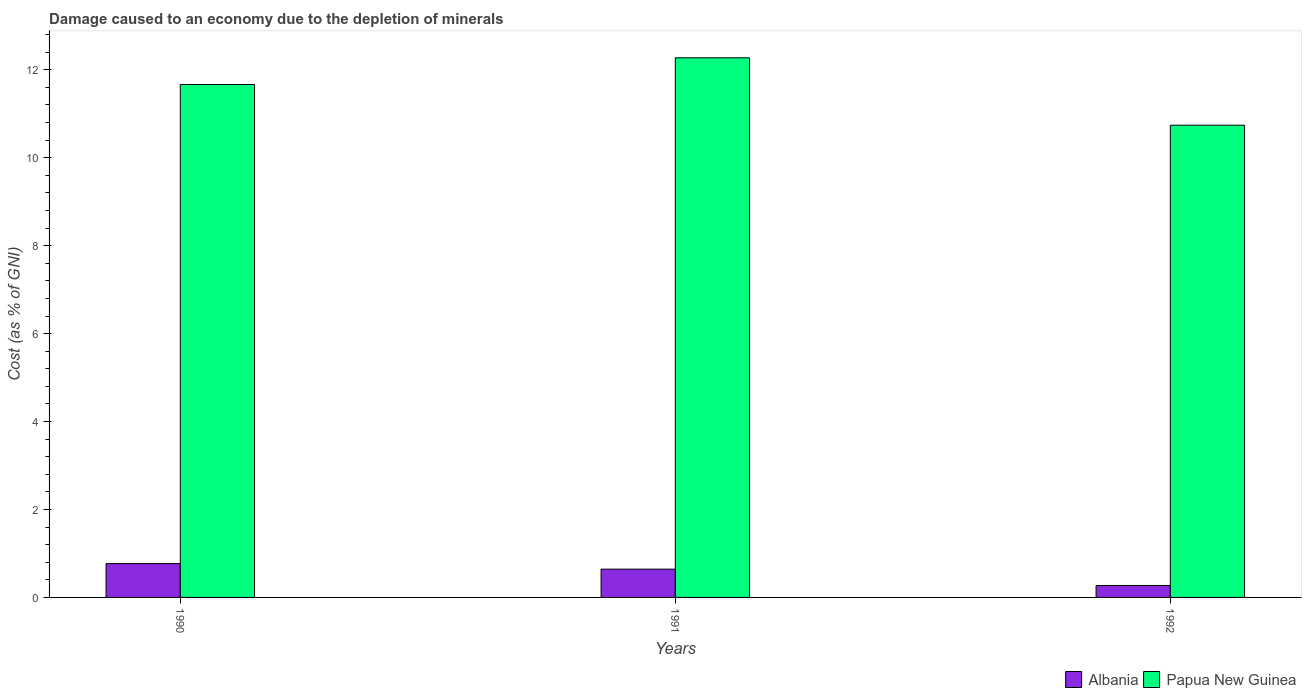Are the number of bars per tick equal to the number of legend labels?
Offer a very short reply. Yes. Are the number of bars on each tick of the X-axis equal?
Your answer should be very brief. Yes. How many bars are there on the 1st tick from the left?
Your response must be concise. 2. How many bars are there on the 3rd tick from the right?
Your response must be concise. 2. What is the label of the 1st group of bars from the left?
Your answer should be very brief. 1990. In how many cases, is the number of bars for a given year not equal to the number of legend labels?
Make the answer very short. 0. What is the cost of damage caused due to the depletion of minerals in Albania in 1991?
Provide a succinct answer. 0.64. Across all years, what is the maximum cost of damage caused due to the depletion of minerals in Albania?
Provide a succinct answer. 0.77. Across all years, what is the minimum cost of damage caused due to the depletion of minerals in Albania?
Your answer should be compact. 0.27. In which year was the cost of damage caused due to the depletion of minerals in Papua New Guinea maximum?
Provide a succinct answer. 1991. In which year was the cost of damage caused due to the depletion of minerals in Papua New Guinea minimum?
Your answer should be very brief. 1992. What is the total cost of damage caused due to the depletion of minerals in Papua New Guinea in the graph?
Provide a short and direct response. 34.68. What is the difference between the cost of damage caused due to the depletion of minerals in Papua New Guinea in 1991 and that in 1992?
Give a very brief answer. 1.53. What is the difference between the cost of damage caused due to the depletion of minerals in Albania in 1992 and the cost of damage caused due to the depletion of minerals in Papua New Guinea in 1990?
Give a very brief answer. -11.4. What is the average cost of damage caused due to the depletion of minerals in Papua New Guinea per year?
Your answer should be compact. 11.56. In the year 1991, what is the difference between the cost of damage caused due to the depletion of minerals in Albania and cost of damage caused due to the depletion of minerals in Papua New Guinea?
Your response must be concise. -11.63. In how many years, is the cost of damage caused due to the depletion of minerals in Albania greater than 8 %?
Your response must be concise. 0. What is the ratio of the cost of damage caused due to the depletion of minerals in Albania in 1990 to that in 1991?
Provide a succinct answer. 1.2. What is the difference between the highest and the second highest cost of damage caused due to the depletion of minerals in Papua New Guinea?
Offer a very short reply. 0.61. What is the difference between the highest and the lowest cost of damage caused due to the depletion of minerals in Albania?
Provide a short and direct response. 0.5. In how many years, is the cost of damage caused due to the depletion of minerals in Papua New Guinea greater than the average cost of damage caused due to the depletion of minerals in Papua New Guinea taken over all years?
Ensure brevity in your answer.  2. What does the 1st bar from the left in 1991 represents?
Your answer should be compact. Albania. What does the 1st bar from the right in 1990 represents?
Keep it short and to the point. Papua New Guinea. How many bars are there?
Offer a terse response. 6. Are all the bars in the graph horizontal?
Ensure brevity in your answer.  No. Are the values on the major ticks of Y-axis written in scientific E-notation?
Offer a terse response. No. Does the graph contain any zero values?
Your response must be concise. No. What is the title of the graph?
Keep it short and to the point. Damage caused to an economy due to the depletion of minerals. Does "Solomon Islands" appear as one of the legend labels in the graph?
Your answer should be compact. No. What is the label or title of the X-axis?
Your answer should be very brief. Years. What is the label or title of the Y-axis?
Provide a short and direct response. Cost (as % of GNI). What is the Cost (as % of GNI) in Albania in 1990?
Offer a very short reply. 0.77. What is the Cost (as % of GNI) of Papua New Guinea in 1990?
Your response must be concise. 11.67. What is the Cost (as % of GNI) of Albania in 1991?
Give a very brief answer. 0.64. What is the Cost (as % of GNI) in Papua New Guinea in 1991?
Offer a very short reply. 12.27. What is the Cost (as % of GNI) of Albania in 1992?
Offer a very short reply. 0.27. What is the Cost (as % of GNI) in Papua New Guinea in 1992?
Keep it short and to the point. 10.74. Across all years, what is the maximum Cost (as % of GNI) in Albania?
Your response must be concise. 0.77. Across all years, what is the maximum Cost (as % of GNI) in Papua New Guinea?
Make the answer very short. 12.27. Across all years, what is the minimum Cost (as % of GNI) of Albania?
Make the answer very short. 0.27. Across all years, what is the minimum Cost (as % of GNI) of Papua New Guinea?
Your answer should be very brief. 10.74. What is the total Cost (as % of GNI) in Albania in the graph?
Your answer should be compact. 1.68. What is the total Cost (as % of GNI) of Papua New Guinea in the graph?
Offer a terse response. 34.68. What is the difference between the Cost (as % of GNI) in Albania in 1990 and that in 1991?
Your response must be concise. 0.13. What is the difference between the Cost (as % of GNI) in Papua New Guinea in 1990 and that in 1991?
Provide a succinct answer. -0.61. What is the difference between the Cost (as % of GNI) in Albania in 1990 and that in 1992?
Give a very brief answer. 0.5. What is the difference between the Cost (as % of GNI) in Papua New Guinea in 1990 and that in 1992?
Your answer should be compact. 0.93. What is the difference between the Cost (as % of GNI) of Albania in 1991 and that in 1992?
Your answer should be compact. 0.37. What is the difference between the Cost (as % of GNI) in Papua New Guinea in 1991 and that in 1992?
Your answer should be compact. 1.53. What is the difference between the Cost (as % of GNI) in Albania in 1990 and the Cost (as % of GNI) in Papua New Guinea in 1991?
Make the answer very short. -11.5. What is the difference between the Cost (as % of GNI) of Albania in 1990 and the Cost (as % of GNI) of Papua New Guinea in 1992?
Provide a succinct answer. -9.97. What is the difference between the Cost (as % of GNI) in Albania in 1991 and the Cost (as % of GNI) in Papua New Guinea in 1992?
Make the answer very short. -10.1. What is the average Cost (as % of GNI) in Albania per year?
Ensure brevity in your answer.  0.56. What is the average Cost (as % of GNI) of Papua New Guinea per year?
Your answer should be compact. 11.56. In the year 1990, what is the difference between the Cost (as % of GNI) of Albania and Cost (as % of GNI) of Papua New Guinea?
Offer a very short reply. -10.9. In the year 1991, what is the difference between the Cost (as % of GNI) of Albania and Cost (as % of GNI) of Papua New Guinea?
Your answer should be compact. -11.63. In the year 1992, what is the difference between the Cost (as % of GNI) in Albania and Cost (as % of GNI) in Papua New Guinea?
Provide a short and direct response. -10.47. What is the ratio of the Cost (as % of GNI) in Albania in 1990 to that in 1991?
Make the answer very short. 1.2. What is the ratio of the Cost (as % of GNI) in Papua New Guinea in 1990 to that in 1991?
Your answer should be compact. 0.95. What is the ratio of the Cost (as % of GNI) in Albania in 1990 to that in 1992?
Make the answer very short. 2.83. What is the ratio of the Cost (as % of GNI) of Papua New Guinea in 1990 to that in 1992?
Offer a very short reply. 1.09. What is the ratio of the Cost (as % of GNI) of Albania in 1991 to that in 1992?
Keep it short and to the point. 2.37. What is the ratio of the Cost (as % of GNI) in Papua New Guinea in 1991 to that in 1992?
Provide a short and direct response. 1.14. What is the difference between the highest and the second highest Cost (as % of GNI) of Albania?
Keep it short and to the point. 0.13. What is the difference between the highest and the second highest Cost (as % of GNI) in Papua New Guinea?
Your answer should be compact. 0.61. What is the difference between the highest and the lowest Cost (as % of GNI) of Albania?
Make the answer very short. 0.5. What is the difference between the highest and the lowest Cost (as % of GNI) in Papua New Guinea?
Offer a terse response. 1.53. 